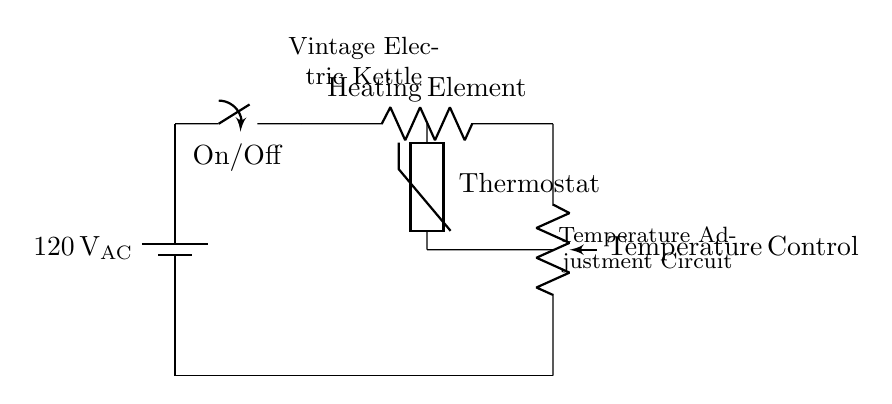What is the voltage of this circuit? The voltage source is indicated as 120 volts AC, which is the potential difference supplied to the circuit components.
Answer: 120 volts AC What component is used for temperature control? The circuit shows a potentiometer labeled "Temperature Control," which allows adjustment of the resistance and consequently the temperature setting in the kettle.
Answer: Potentiometer How does the thermostat interact in this circuit? The thermostat, depicted as a thermistor, is connected in parallel with the heating element. It’s responsible for detecting the temperature and providing feedback to adjust the heating accordingly.
Answer: Thermistor Which component provides the main power supply for the kettle? The circuit features a battery symbol labeled "120 V AC." This represents the main power supply that energizes the kettle and its components.
Answer: Battery What is the role of the heating element in this circuit? The heating element is connected directly to the voltage source and is responsible for converting electrical energy into heat energy to heat the water in the kettle.
Answer: Heating Element How are the components connected in the circuit? The components are connected in a series-parallel combination where the battery supplies power to the heating element, and the thermostat and potentiometer regulate the temperature.
Answer: Series-parallel 